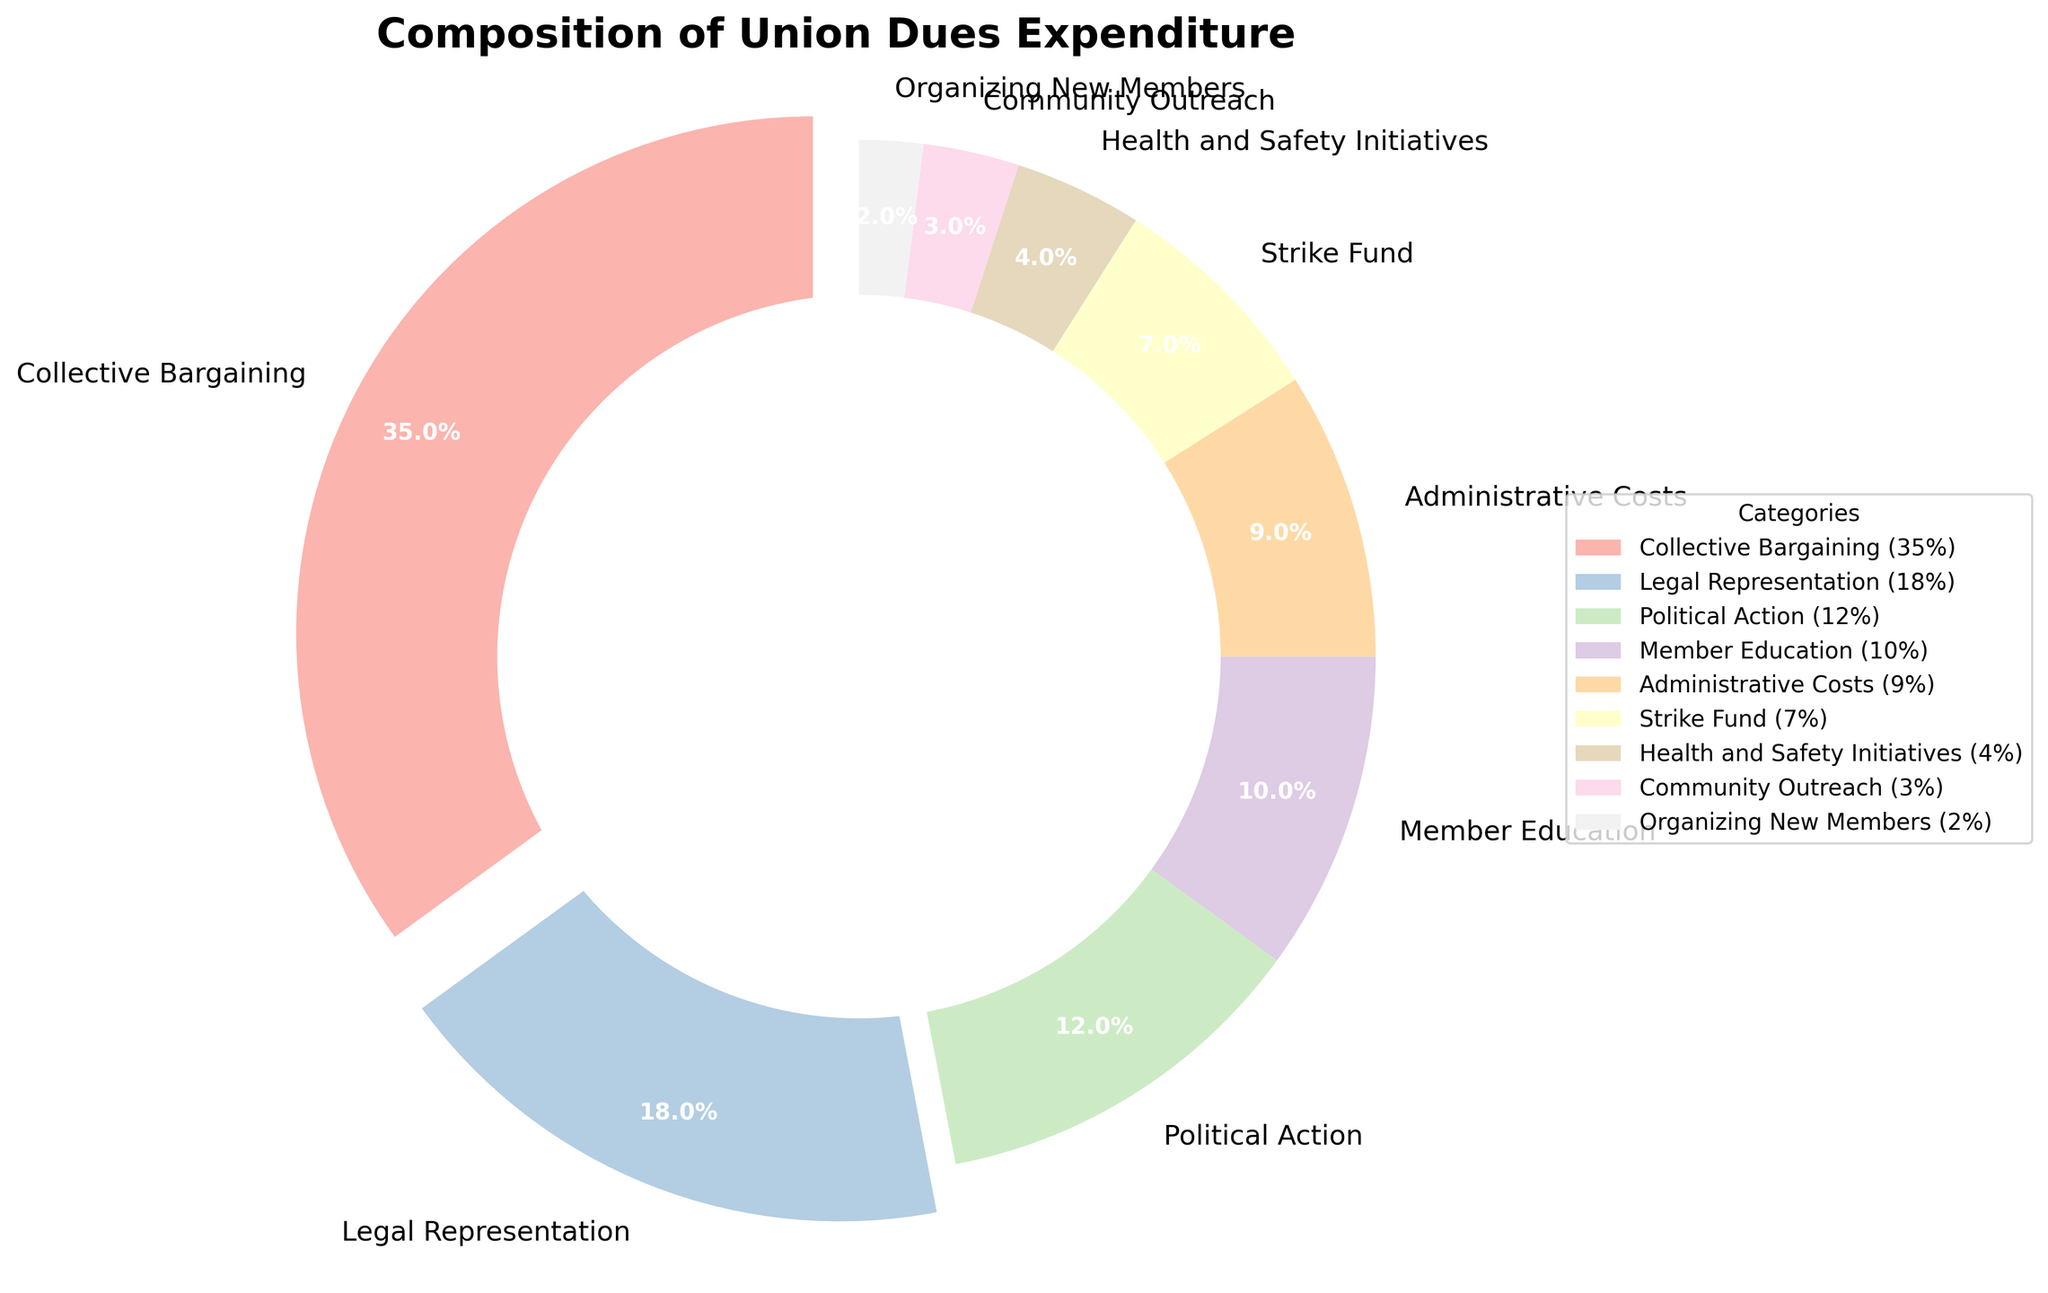What are the three largest expenditure categories in the union's dues? The three largest expenditure categories are Collective Bargaining, Legal Representation, and Political Action. This can be determined by the segment sizes and the percentage labels on the pie chart.
Answer: Collective Bargaining, Legal Representation, Political Action What is the combined percentage of Administrative Costs and Strike Fund? From the pie chart, Administrative Costs are 9% and Strike Fund is 7%. Adding these together gives 9% + 7% = 16%.
Answer: 16% Which category has a larger percentage, Member Education or Health and Safety Initiatives? By comparing the percentage labels on the pie chart, Member Education is 10% while Health and Safety Initiatives are 4%. Therefore, Member Education is larger.
Answer: Member Education What is the difference in expenditure between Political Action and Community Outreach? The pie chart shows that Political Action is 12% and Community Outreach is 3%. Subtracting these gives 12% - 3% = 9%.
Answer: 9% How does the expenditure on Legal Representation compare to that on Member Education? Legal Representation accounts for 18% while Member Education accounts for 10%. Therefore, Legal Representation's expenditure is higher.
Answer: Legal Representation is higher What percentage of the union dues is spent on Health and Safety Initiatives and Organizing New Members combined? Health and Safety Initiatives are 4% and Organizing New Members is 2%. Adding these together gives 4% + 2% = 6%.
Answer: 6% Which categories are highlighted or exploded in the pie chart? The pie chart explodes or highlights categories with percentages above 15%. Based on the provided data and visual attributes, these categories are Collective Bargaining and Legal Representation.
Answer: Collective Bargaining and Legal Representation Which category has the smallest expenditure, and what percentage is it? The category with the smallest expenditure is Organizing New Members, which is 2% based on the pie chart.
Answer: Organizing New Members, 2% What is the total percentage of expenditures allocated to Collective Bargaining, Political Action, and Community Outreach? Adding the percentages of Collective Bargaining (35%), Political Action (12%), and Community Outreach (3%) gives 35% + 12% + 3% = 50%.
Answer: 50% 